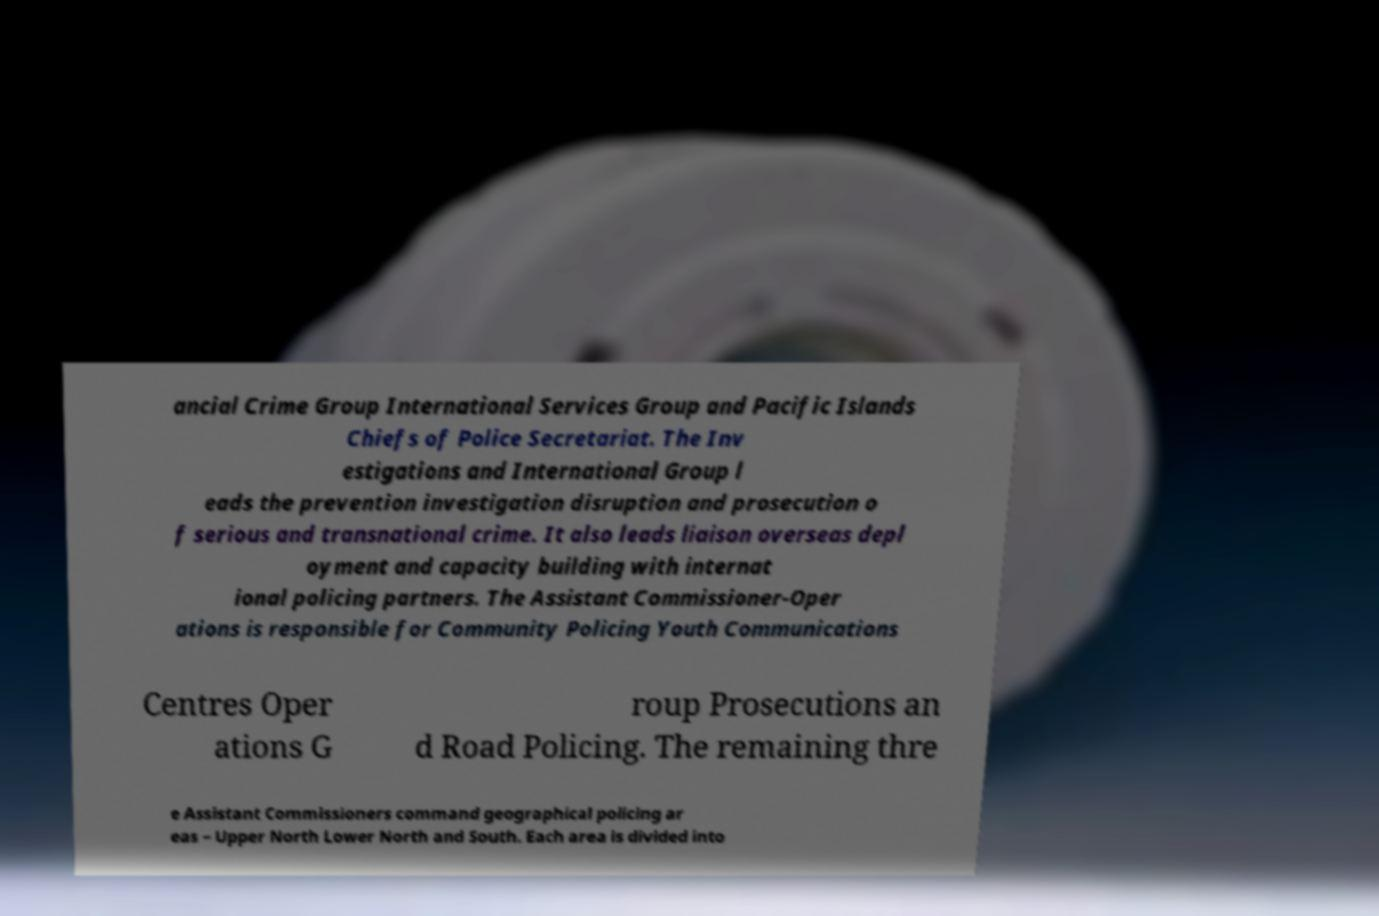What messages or text are displayed in this image? I need them in a readable, typed format. ancial Crime Group International Services Group and Pacific Islands Chiefs of Police Secretariat. The Inv estigations and International Group l eads the prevention investigation disruption and prosecution o f serious and transnational crime. It also leads liaison overseas depl oyment and capacity building with internat ional policing partners. The Assistant Commissioner-Oper ations is responsible for Community Policing Youth Communications Centres Oper ations G roup Prosecutions an d Road Policing. The remaining thre e Assistant Commissioners command geographical policing ar eas – Upper North Lower North and South. Each area is divided into 